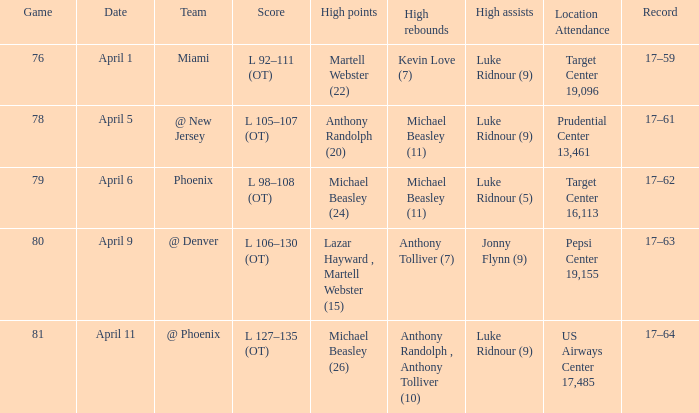What was the count of unique high rebound results in the 76th game? 1.0. 